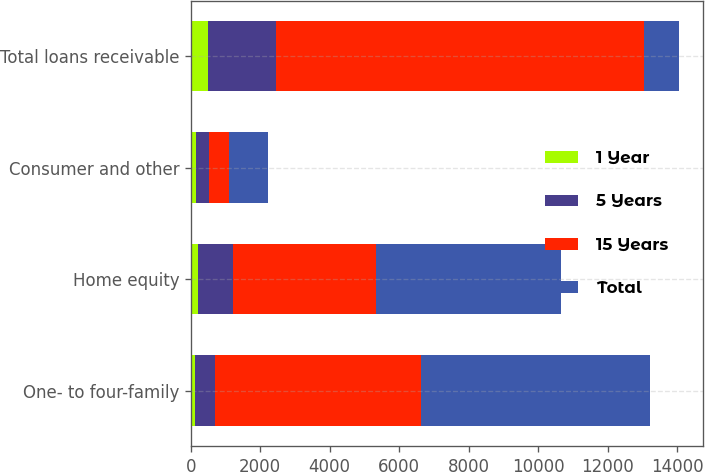<chart> <loc_0><loc_0><loc_500><loc_500><stacked_bar_chart><ecel><fcel>One- to four-family<fcel>Home equity<fcel>Consumer and other<fcel>Total loans receivable<nl><fcel>1 Year<fcel>127.1<fcel>220.9<fcel>144.4<fcel>492.4<nl><fcel>5 Years<fcel>573.9<fcel>998.9<fcel>384.2<fcel>1957<nl><fcel>15 Years<fcel>5914.8<fcel>4108.9<fcel>584.6<fcel>10608.3<nl><fcel>Total<fcel>6615.8<fcel>5328.7<fcel>1113.2<fcel>998.9<nl></chart> 